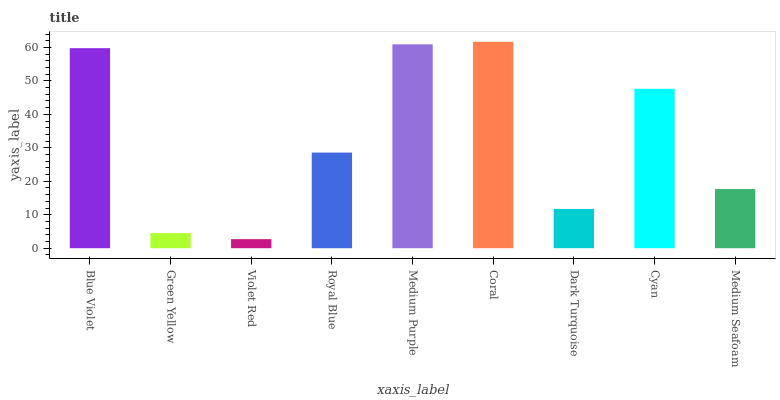Is Violet Red the minimum?
Answer yes or no. Yes. Is Coral the maximum?
Answer yes or no. Yes. Is Green Yellow the minimum?
Answer yes or no. No. Is Green Yellow the maximum?
Answer yes or no. No. Is Blue Violet greater than Green Yellow?
Answer yes or no. Yes. Is Green Yellow less than Blue Violet?
Answer yes or no. Yes. Is Green Yellow greater than Blue Violet?
Answer yes or no. No. Is Blue Violet less than Green Yellow?
Answer yes or no. No. Is Royal Blue the high median?
Answer yes or no. Yes. Is Royal Blue the low median?
Answer yes or no. Yes. Is Violet Red the high median?
Answer yes or no. No. Is Medium Purple the low median?
Answer yes or no. No. 